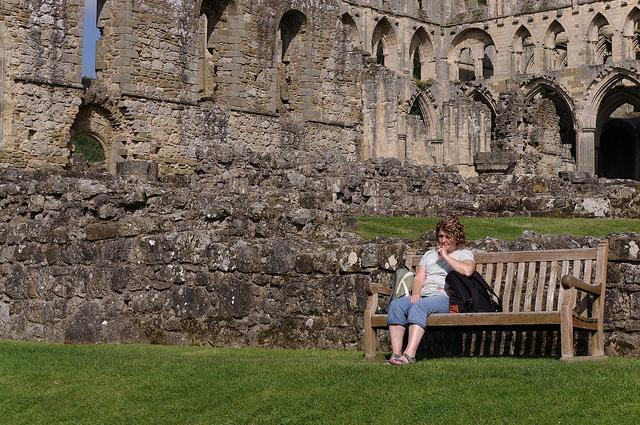What activity happens near and in this structure? Please explain your reasoning. tourism. There is a ruin that people would want to visit to look at. 